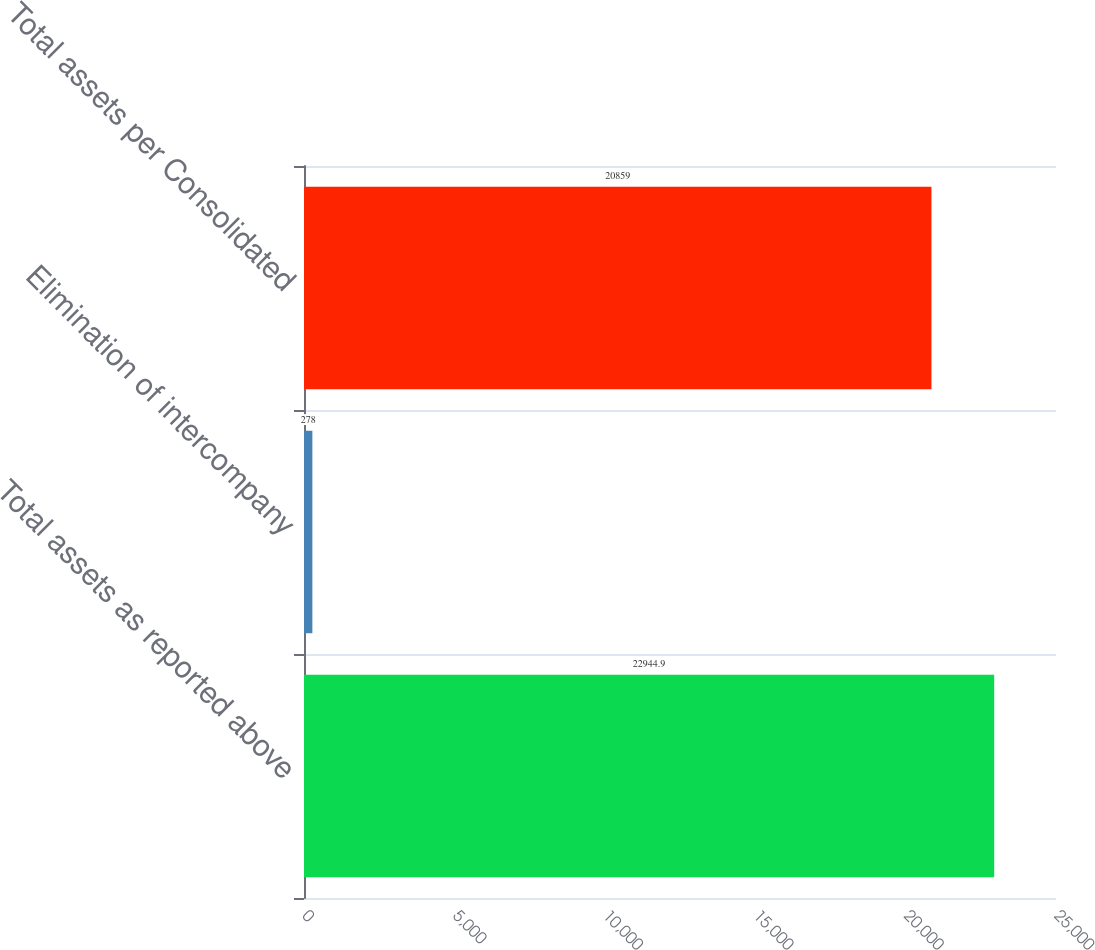Convert chart. <chart><loc_0><loc_0><loc_500><loc_500><bar_chart><fcel>Total assets as reported above<fcel>Elimination of intercompany<fcel>Total assets per Consolidated<nl><fcel>22944.9<fcel>278<fcel>20859<nl></chart> 